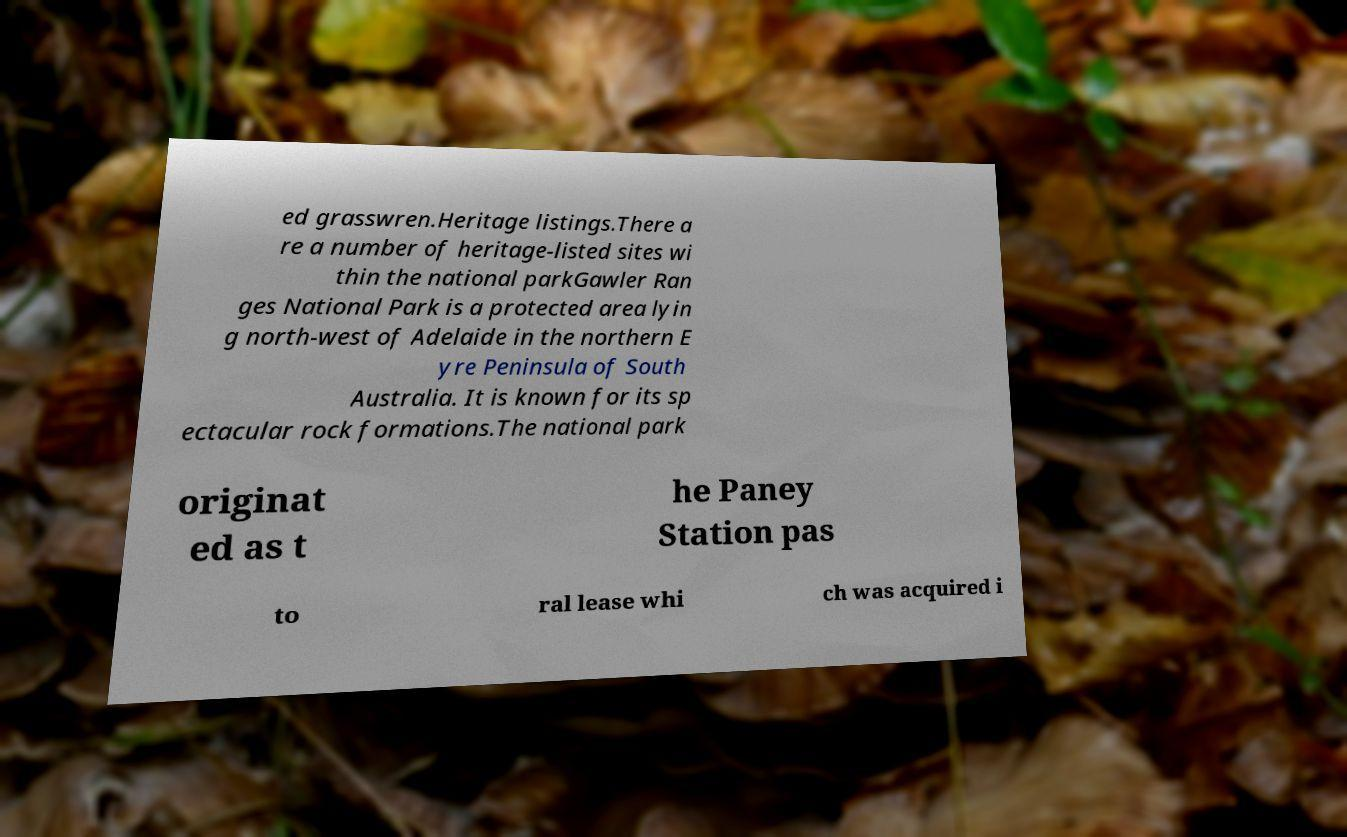Could you assist in decoding the text presented in this image and type it out clearly? ed grasswren.Heritage listings.There a re a number of heritage-listed sites wi thin the national parkGawler Ran ges National Park is a protected area lyin g north-west of Adelaide in the northern E yre Peninsula of South Australia. It is known for its sp ectacular rock formations.The national park originat ed as t he Paney Station pas to ral lease whi ch was acquired i 